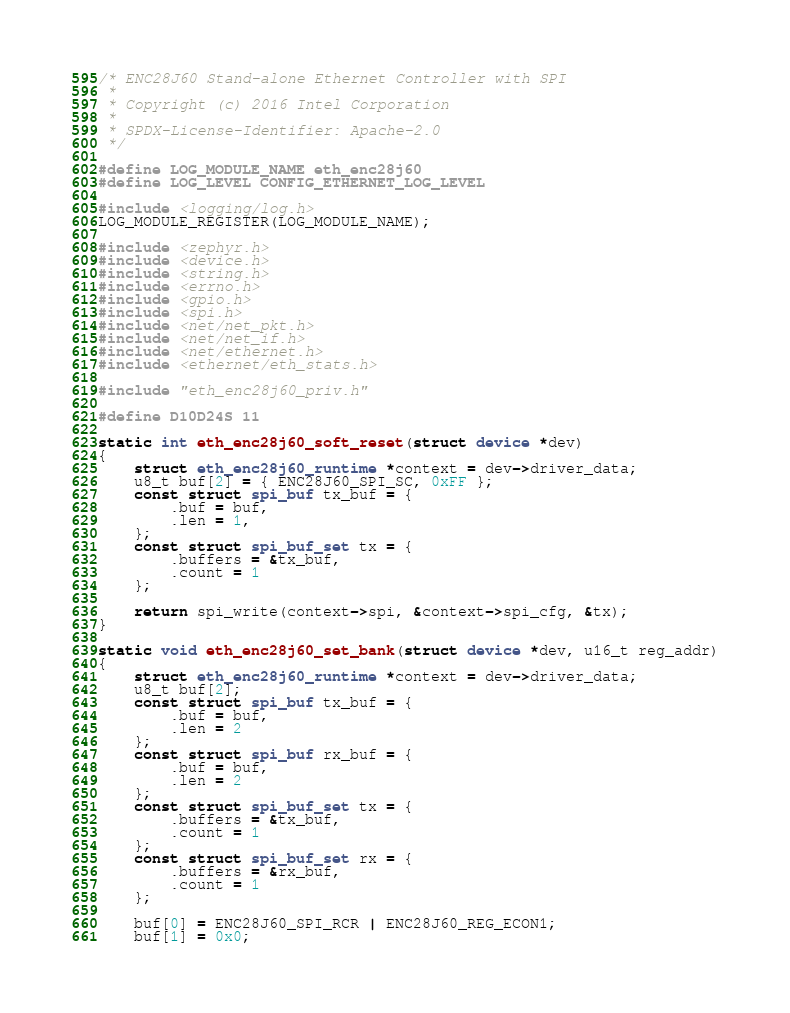Convert code to text. <code><loc_0><loc_0><loc_500><loc_500><_C_>/* ENC28J60 Stand-alone Ethernet Controller with SPI
 *
 * Copyright (c) 2016 Intel Corporation
 *
 * SPDX-License-Identifier: Apache-2.0
 */

#define LOG_MODULE_NAME eth_enc28j60
#define LOG_LEVEL CONFIG_ETHERNET_LOG_LEVEL

#include <logging/log.h>
LOG_MODULE_REGISTER(LOG_MODULE_NAME);

#include <zephyr.h>
#include <device.h>
#include <string.h>
#include <errno.h>
#include <gpio.h>
#include <spi.h>
#include <net/net_pkt.h>
#include <net/net_if.h>
#include <net/ethernet.h>
#include <ethernet/eth_stats.h>

#include "eth_enc28j60_priv.h"

#define D10D24S 11

static int eth_enc28j60_soft_reset(struct device *dev)
{
	struct eth_enc28j60_runtime *context = dev->driver_data;
	u8_t buf[2] = { ENC28J60_SPI_SC, 0xFF };
	const struct spi_buf tx_buf = {
		.buf = buf,
		.len = 1,
	};
	const struct spi_buf_set tx = {
		.buffers = &tx_buf,
		.count = 1
	};

	return spi_write(context->spi, &context->spi_cfg, &tx);
}

static void eth_enc28j60_set_bank(struct device *dev, u16_t reg_addr)
{
	struct eth_enc28j60_runtime *context = dev->driver_data;
	u8_t buf[2];
	const struct spi_buf tx_buf = {
		.buf = buf,
		.len = 2
	};
	const struct spi_buf rx_buf = {
		.buf = buf,
		.len = 2
	};
	const struct spi_buf_set tx = {
		.buffers = &tx_buf,
		.count = 1
	};
	const struct spi_buf_set rx = {
		.buffers = &rx_buf,
		.count = 1
	};

	buf[0] = ENC28J60_SPI_RCR | ENC28J60_REG_ECON1;
	buf[1] = 0x0;
</code> 